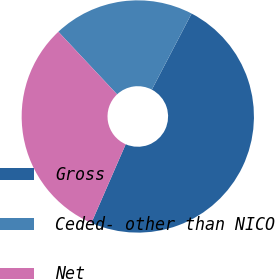Convert chart. <chart><loc_0><loc_0><loc_500><loc_500><pie_chart><fcel>Gross<fcel>Ceded- other than NICO<fcel>Net<nl><fcel>48.88%<fcel>19.65%<fcel>31.47%<nl></chart> 